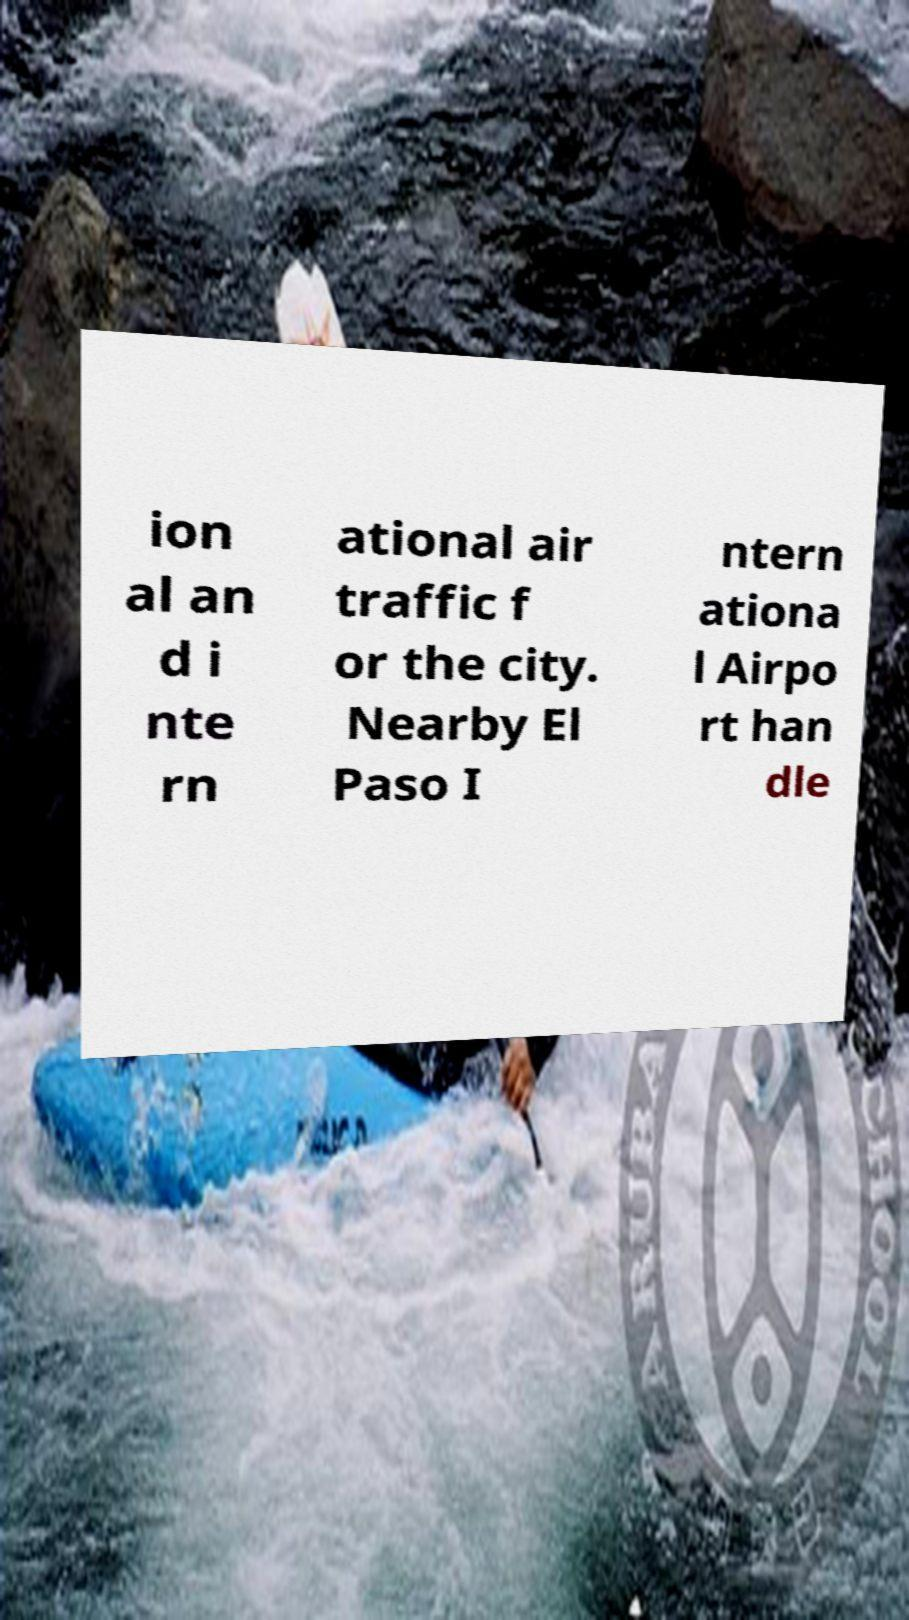What messages or text are displayed in this image? I need them in a readable, typed format. ion al an d i nte rn ational air traffic f or the city. Nearby El Paso I ntern ationa l Airpo rt han dle 